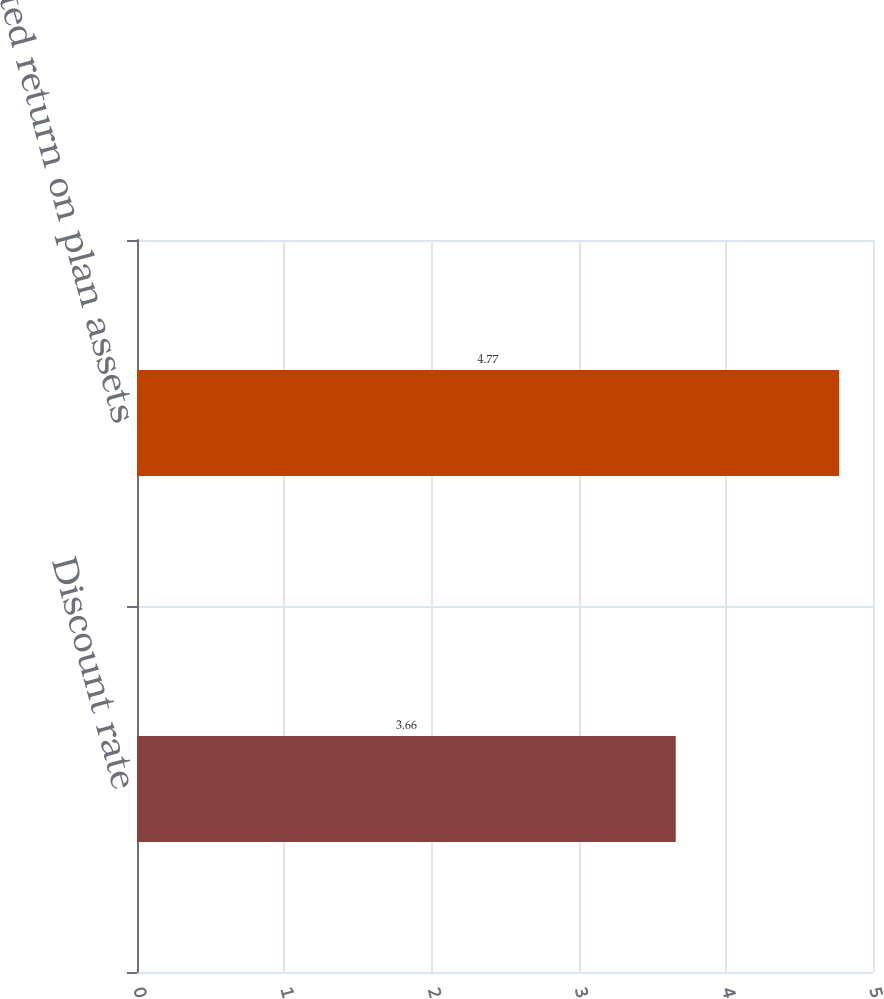Convert chart to OTSL. <chart><loc_0><loc_0><loc_500><loc_500><bar_chart><fcel>Discount rate<fcel>Expected return on plan assets<nl><fcel>3.66<fcel>4.77<nl></chart> 